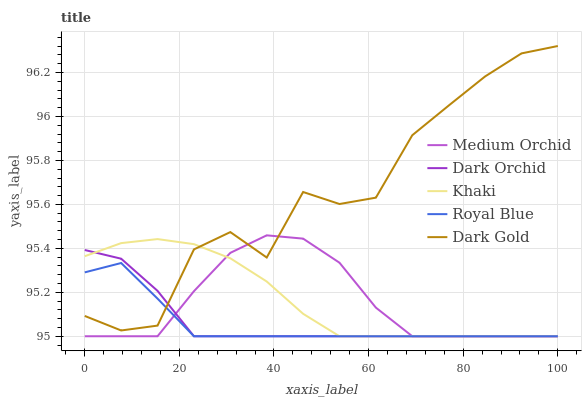Does Royal Blue have the minimum area under the curve?
Answer yes or no. Yes. Does Dark Gold have the maximum area under the curve?
Answer yes or no. Yes. Does Medium Orchid have the minimum area under the curve?
Answer yes or no. No. Does Medium Orchid have the maximum area under the curve?
Answer yes or no. No. Is Khaki the smoothest?
Answer yes or no. Yes. Is Dark Gold the roughest?
Answer yes or no. Yes. Is Medium Orchid the smoothest?
Answer yes or no. No. Is Medium Orchid the roughest?
Answer yes or no. No. Does Dark Gold have the lowest value?
Answer yes or no. No. Does Dark Gold have the highest value?
Answer yes or no. Yes. Does Medium Orchid have the highest value?
Answer yes or no. No. 